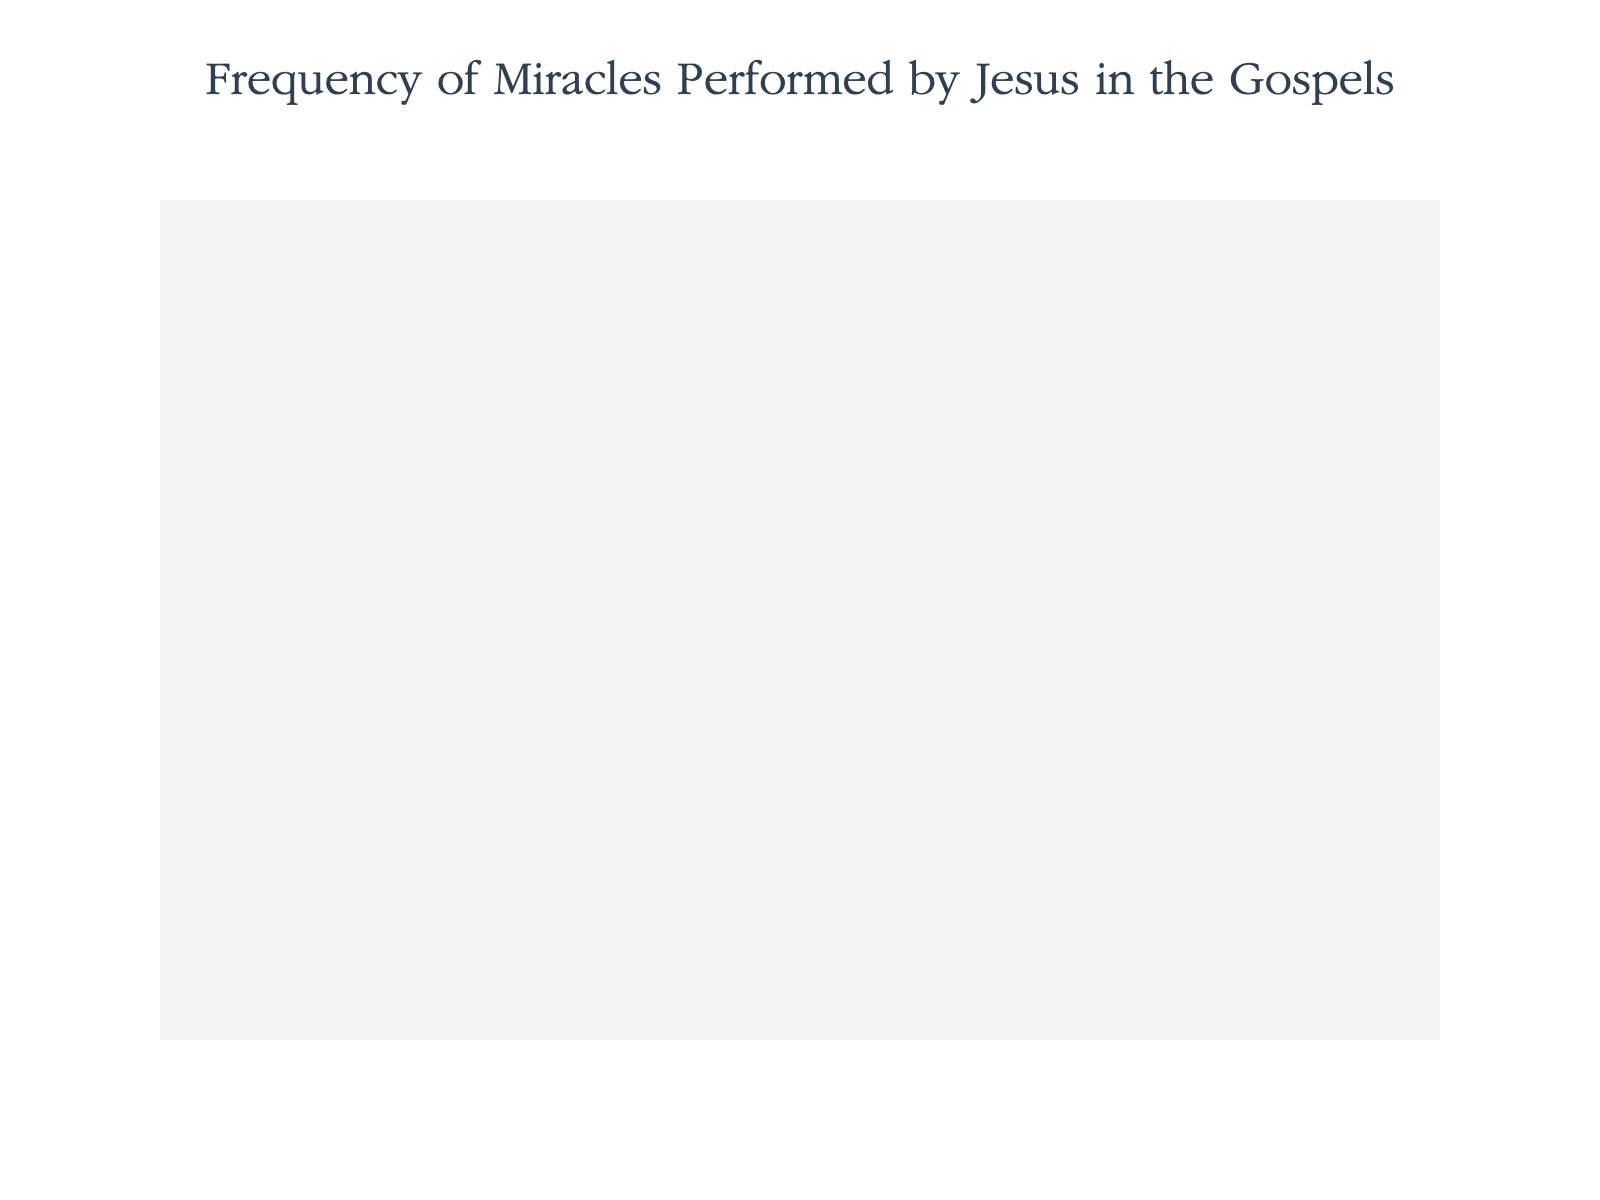What is the title of the plot? The title of the plot is typically displayed at the top and is written in a more prominent font size compared to other texts in the plot. By looking at the plot, the title can be observed directly.
Answer: Frequency of Miracles Performed by Jesus in the Gospels Which type of miracle performed by Jesus appears most frequently? By counting the icons for each miracle type, we can observe that the "Healing" type has the most icons.
Answer: Healing How many more healing miracles are there than nature miracles? First, determine the number of icons representing healing miracles (30) and nature miracles (10). Subtract 10 from 30 to get the difference.
Answer: 20 How many different types of miracles are shown in the plot? The legend or the different icon types can be counted to determine the number of unique miracle types. Each type of symbol represents a different type of miracle.
Answer: 6 Which miracle type has the least frequency, and how many times does it appear? By examining the number of icons for each type, "Walking on Water" and "Turning Water into Wine" each appear only once, and hence have the least frequency.
Answer: Walking on Water or Turning Water into Wine (1 each) What is the total number of miracles performed by Jesus in the Gospels according to this plot? Add up the counts of miracles for all types: 30 (healing) + 10 (nature) + 7 (exorcism) + 3 (raising the dead) + 2 (feeding multitudes) + 1 (walking on water) + 1 (turning water into wine). The total is 54.
Answer: 54 What percentage of the total miracles are exorcisms? First, calculate the total number of miracles: 54. There are 7 exorcisms. The percentage is calculated as (7/54) * 100%. This gives approximately 12.96%.
Answer: 12.96% How many miracle types have counts greater than 2? By reviewing the icons shown, "Healing" (30), "Nature" (10), and "Exorcism" (7), and "Raising the Dead" (3) each have counts greater than 2, which makes for four types.
Answer: 4 Compare the combined frequency of feeding multitudes and raising the dead to the frequency of nature miracles. Which is greater, and by how much? The combined frequency of feeding multitudes (2) and raising the dead (3) is 2 + 3 = 5. The frequency of nature miracles is 10. Subtract the combined frequency from the frequency of nature miracles: 10 - 5 = 5. Nature miracles are greater by 5.
Answer: Nature miracles by 5 